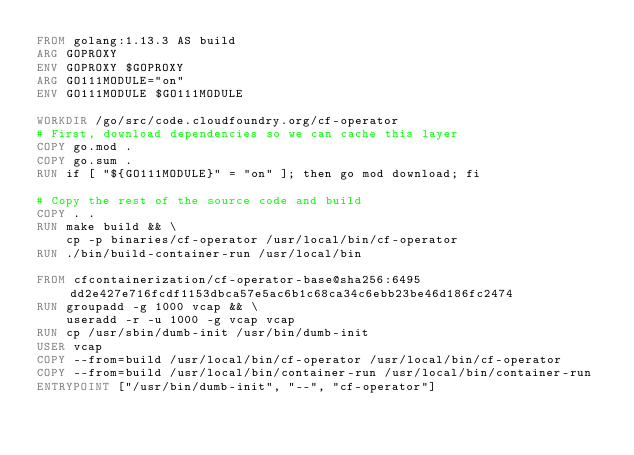<code> <loc_0><loc_0><loc_500><loc_500><_Dockerfile_>FROM golang:1.13.3 AS build
ARG GOPROXY
ENV GOPROXY $GOPROXY
ARG GO111MODULE="on"
ENV GO111MODULE $GO111MODULE

WORKDIR /go/src/code.cloudfoundry.org/cf-operator
# First, download dependencies so we can cache this layer
COPY go.mod .
COPY go.sum .
RUN if [ "${GO111MODULE}" = "on" ]; then go mod download; fi

# Copy the rest of the source code and build
COPY . .
RUN make build && \
    cp -p binaries/cf-operator /usr/local/bin/cf-operator
RUN ./bin/build-container-run /usr/local/bin

FROM cfcontainerization/cf-operator-base@sha256:6495dd2e427e716fcdf1153dbca57e5ac6b1c68ca34c6ebb23be46d186fc2474
RUN groupadd -g 1000 vcap && \
    useradd -r -u 1000 -g vcap vcap
RUN cp /usr/sbin/dumb-init /usr/bin/dumb-init
USER vcap
COPY --from=build /usr/local/bin/cf-operator /usr/local/bin/cf-operator
COPY --from=build /usr/local/bin/container-run /usr/local/bin/container-run
ENTRYPOINT ["/usr/bin/dumb-init", "--", "cf-operator"]
</code> 